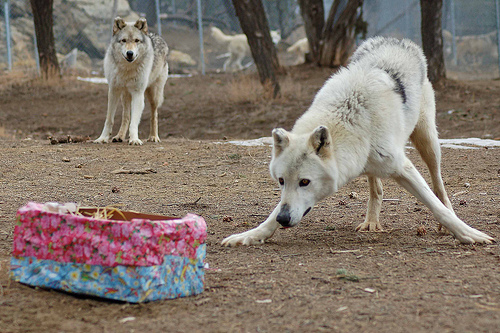<image>
Is there a box under the dog? No. The box is not positioned under the dog. The vertical relationship between these objects is different. Is there a wolf next to the wolf? No. The wolf is not positioned next to the wolf. They are located in different areas of the scene. 